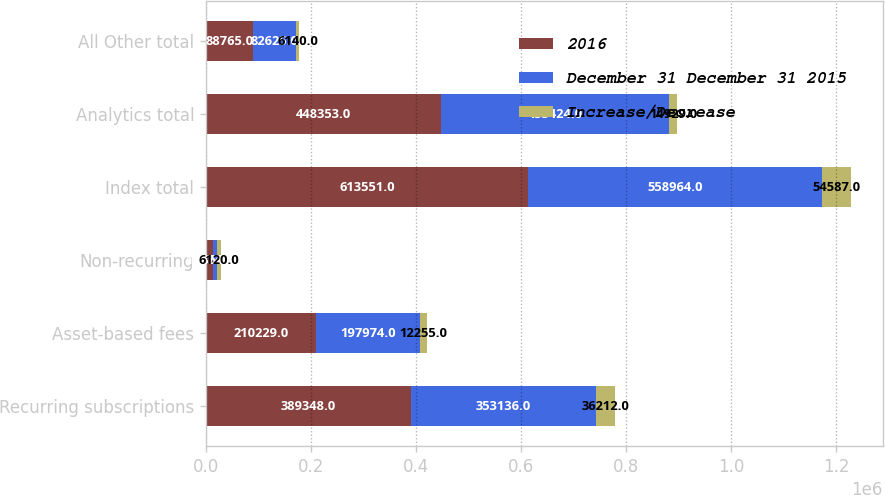<chart> <loc_0><loc_0><loc_500><loc_500><stacked_bar_chart><ecel><fcel>Recurring subscriptions<fcel>Asset-based fees<fcel>Non-recurring<fcel>Index total<fcel>Analytics total<fcel>All Other total<nl><fcel>2016<fcel>389348<fcel>210229<fcel>13974<fcel>613551<fcel>448353<fcel>88765<nl><fcel>December 31 December 31 2015<fcel>353136<fcel>197974<fcel>7854<fcel>558964<fcel>433424<fcel>82625<nl><fcel>Increase/Decrease<fcel>36212<fcel>12255<fcel>6120<fcel>54587<fcel>14929<fcel>6140<nl></chart> 